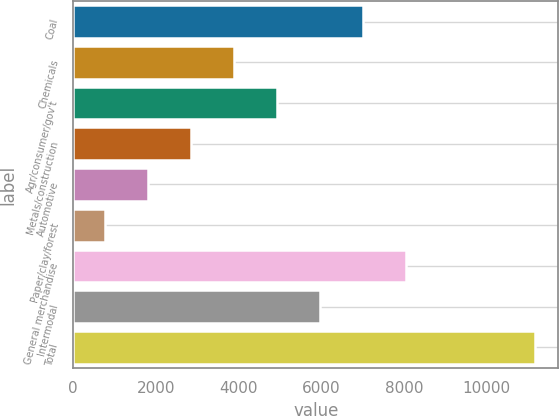Convert chart to OTSL. <chart><loc_0><loc_0><loc_500><loc_500><bar_chart><fcel>Coal<fcel>Chemicals<fcel>Agr/consumer/gov't<fcel>Metals/construction<fcel>Automotive<fcel>Paper/clay/forest<fcel>General merchandise<fcel>Intermodal<fcel>Total<nl><fcel>7005.6<fcel>3880.8<fcel>4922.4<fcel>2839.2<fcel>1797.6<fcel>756<fcel>8047.2<fcel>5964<fcel>11172<nl></chart> 